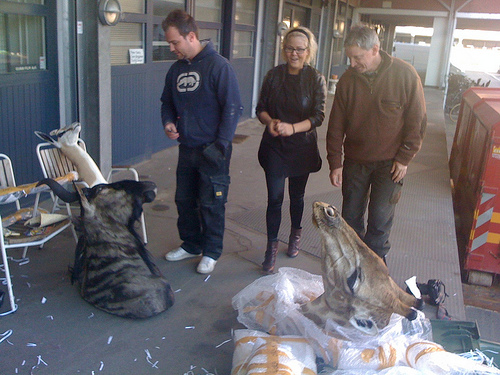<image>
Is there a dumpster in front of the man? No. The dumpster is not in front of the man. The spatial positioning shows a different relationship between these objects. 